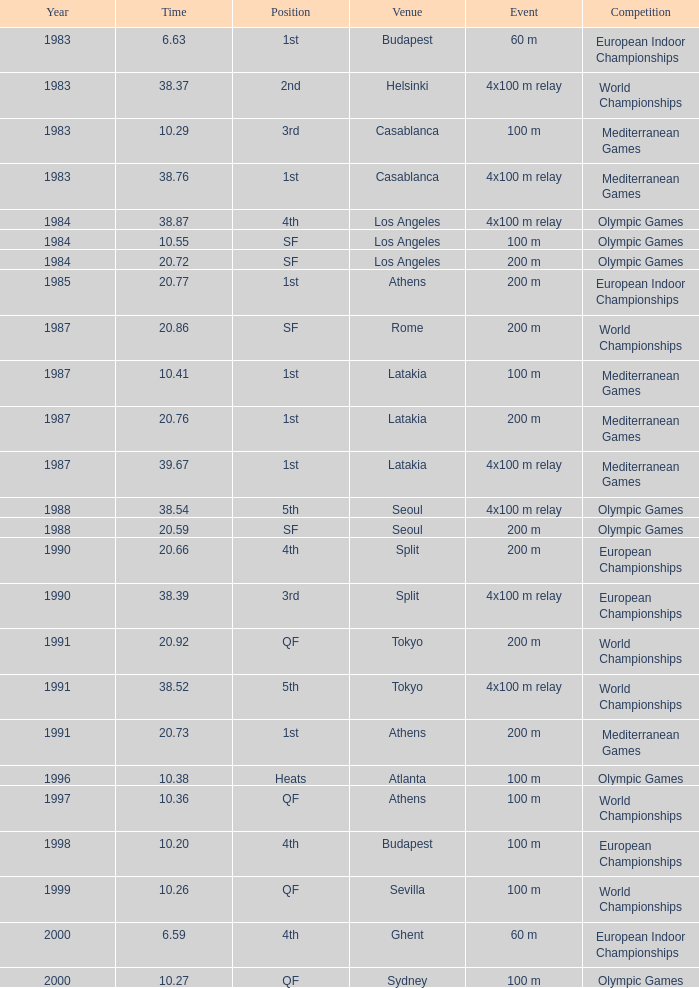What Venue has a Year smaller than 1991, Time larger than 10.29, Competition of mediterranean games, and Event of 4x100 m relay? Casablanca, Latakia. 